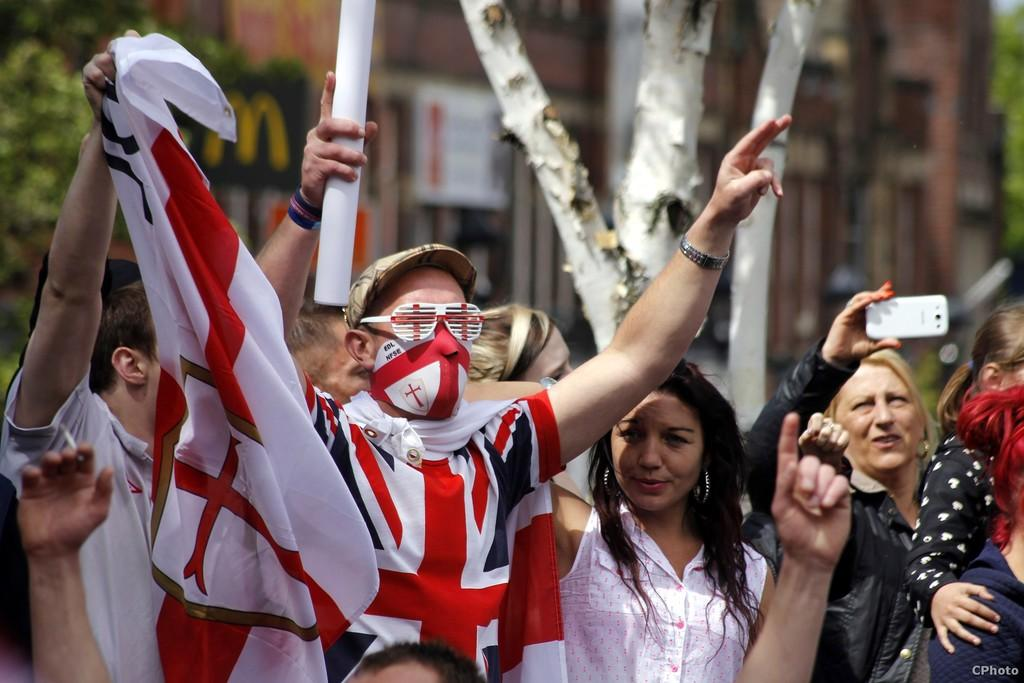How many people are in the image? There are persons in the image, but the exact number is not specified. What is one person doing in the image? One person is holding a mobile in the image. What can be seen in the background of the image? There is a building in the background of the image. What type of vegetation is present in the image? There is a tree in the image. What type of brush is being used to paint the lunch in the image? There is no brush or lunch present in the image. Can you tell me how many kitties are sitting on the tree in the image? There are no kitties present in the image; only a tree is mentioned. 